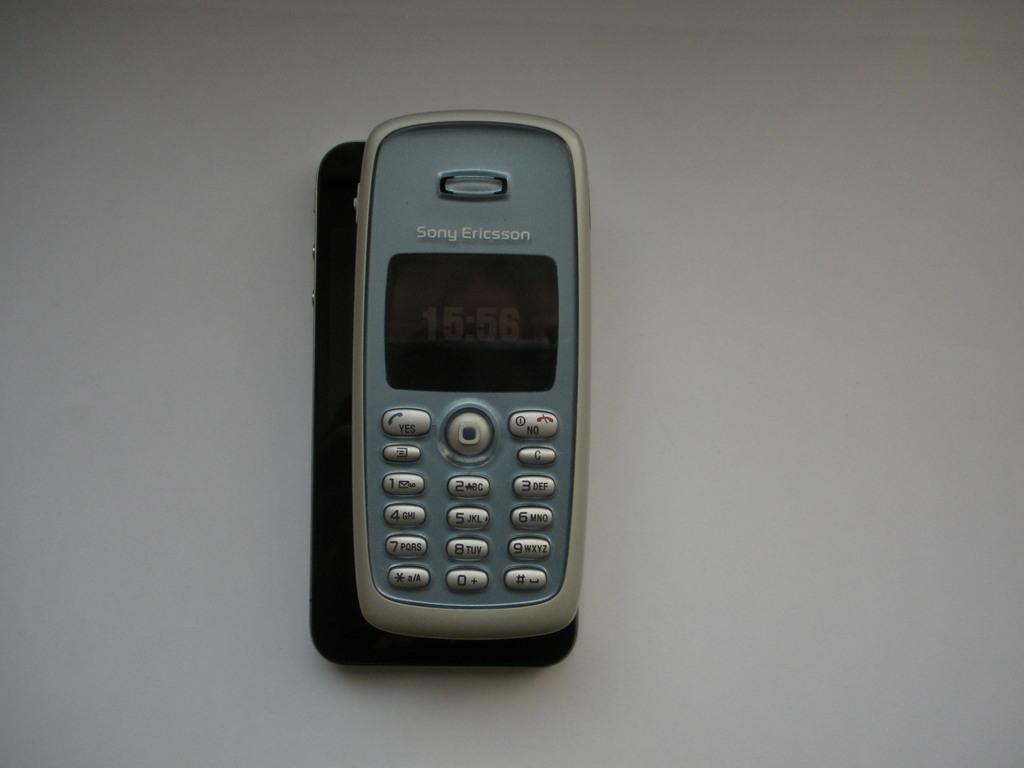What brand of phone is this?
Provide a short and direct response. Sony ericsson. What time is it?
Your answer should be compact. 15:56. 